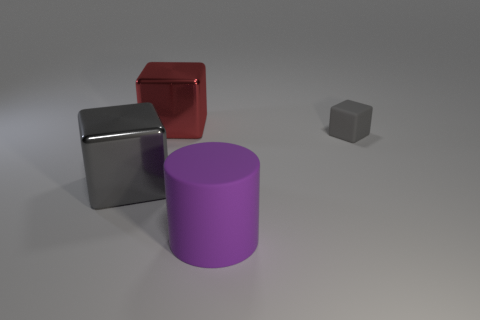Subtract all red shiny blocks. How many blocks are left? 2 Subtract all brown spheres. How many gray cubes are left? 2 Subtract all blue blocks. Subtract all brown spheres. How many blocks are left? 3 Subtract all cylinders. How many objects are left? 3 Add 1 large blue metal blocks. How many objects exist? 5 Subtract all gray metal blocks. Subtract all matte objects. How many objects are left? 1 Add 4 big metallic things. How many big metallic things are left? 6 Add 4 red things. How many red things exist? 5 Subtract 0 brown balls. How many objects are left? 4 